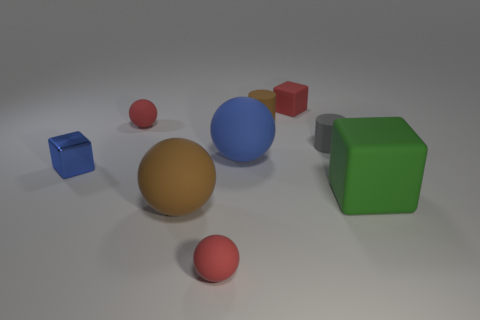Subtract 1 balls. How many balls are left? 3 Subtract all cylinders. How many objects are left? 7 Subtract all red cubes. Subtract all small red rubber cubes. How many objects are left? 7 Add 6 tiny gray things. How many tiny gray things are left? 7 Add 9 big brown matte spheres. How many big brown matte spheres exist? 10 Subtract 0 cyan balls. How many objects are left? 9 